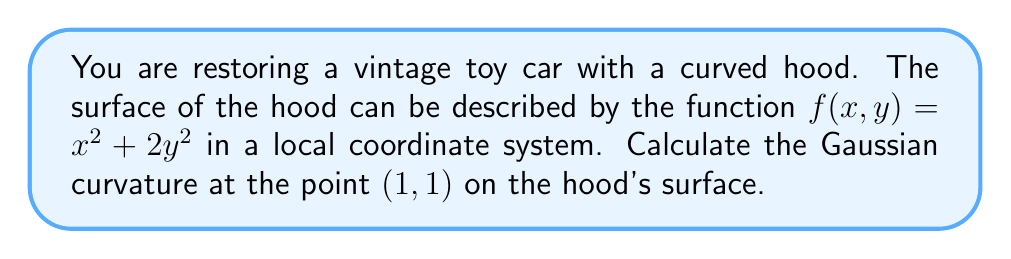Teach me how to tackle this problem. To find the Gaussian curvature of the surface at the point (1, 1), we need to follow these steps:

1. Calculate the first and second partial derivatives of $f(x,y)$:
   $$f_x = 2x, \quad f_y = 4y$$
   $$f_{xx} = 2, \quad f_{yy} = 4, \quad f_{xy} = 0$$

2. Compute the coefficients of the first fundamental form:
   $$E = 1 + f_x^2 = 1 + (2x)^2 = 1 + 4x^2$$
   $$F = f_x f_y = (2x)(4y) = 8xy$$
   $$G = 1 + f_y^2 = 1 + (4y)^2 = 1 + 16y^2$$

3. Calculate the coefficients of the second fundamental form:
   $$L = \frac{f_{xx}}{\sqrt{1 + f_x^2 + f_y^2}} = \frac{2}{\sqrt{1 + 4x^2 + 16y^2}}$$
   $$M = \frac{f_{xy}}{\sqrt{1 + f_x^2 + f_y^2}} = 0$$
   $$N = \frac{f_{yy}}{\sqrt{1 + f_x^2 + f_y^2}} = \frac{4}{\sqrt{1 + 4x^2 + 16y^2}}$$

4. The Gaussian curvature K is given by:
   $$K = \frac{LN - M^2}{EG - F^2}$$

5. Substitute the values at the point (1, 1):
   $$E = 1 + 4(1)^2 = 5$$
   $$F = 8(1)(1) = 8$$
   $$G = 1 + 16(1)^2 = 17$$
   $$L = \frac{2}{\sqrt{1 + 4(1)^2 + 16(1)^2}} = \frac{2}{\sqrt{21}}$$
   $$M = 0$$
   $$N = \frac{4}{\sqrt{1 + 4(1)^2 + 16(1)^2}} = \frac{4}{\sqrt{21}}$$

6. Calculate the Gaussian curvature:
   $$K = \frac{(\frac{2}{\sqrt{21}})(\frac{4}{\sqrt{21}}) - 0^2}{(5)(17) - 8^2}$$
   $$= \frac{\frac{8}{21}}{85 - 64} = \frac{\frac{8}{21}}{21} = \frac{8}{441}$$

Therefore, the Gaussian curvature at the point (1, 1) on the hood's surface is $\frac{8}{441}$.
Answer: $\frac{8}{441}$ 